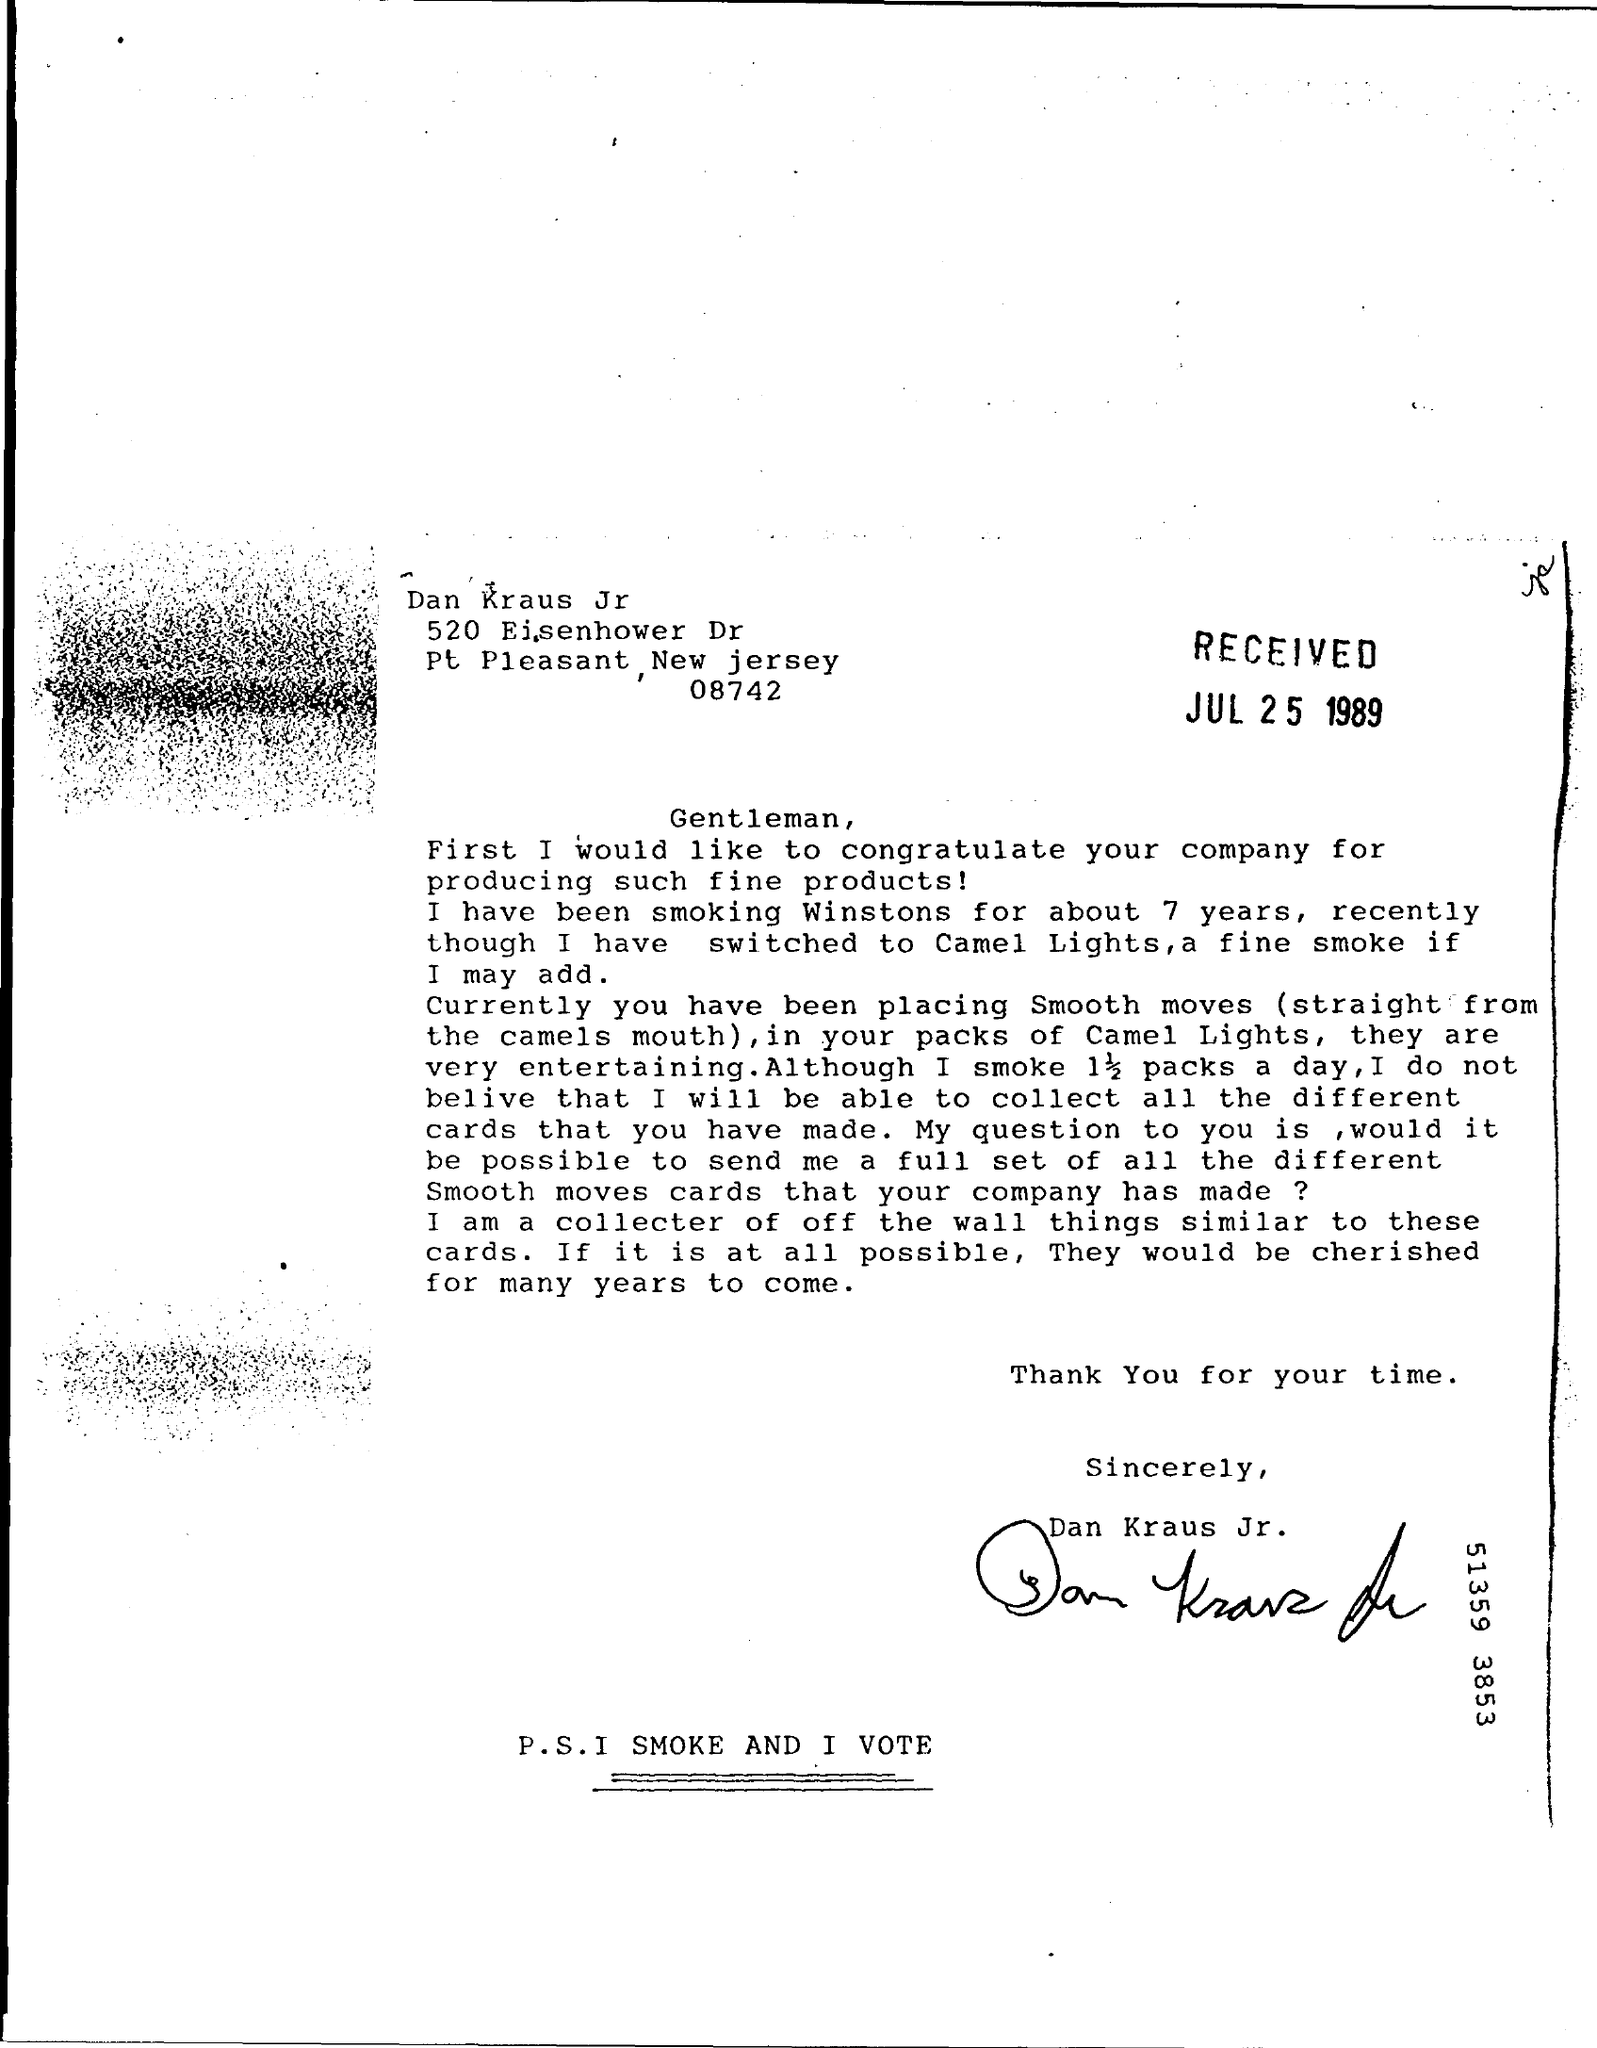Identify some key points in this picture. The sign at the end of the letter was that of Dan Kraus Jr. The date on which this letter was received is July 25, 1989. 